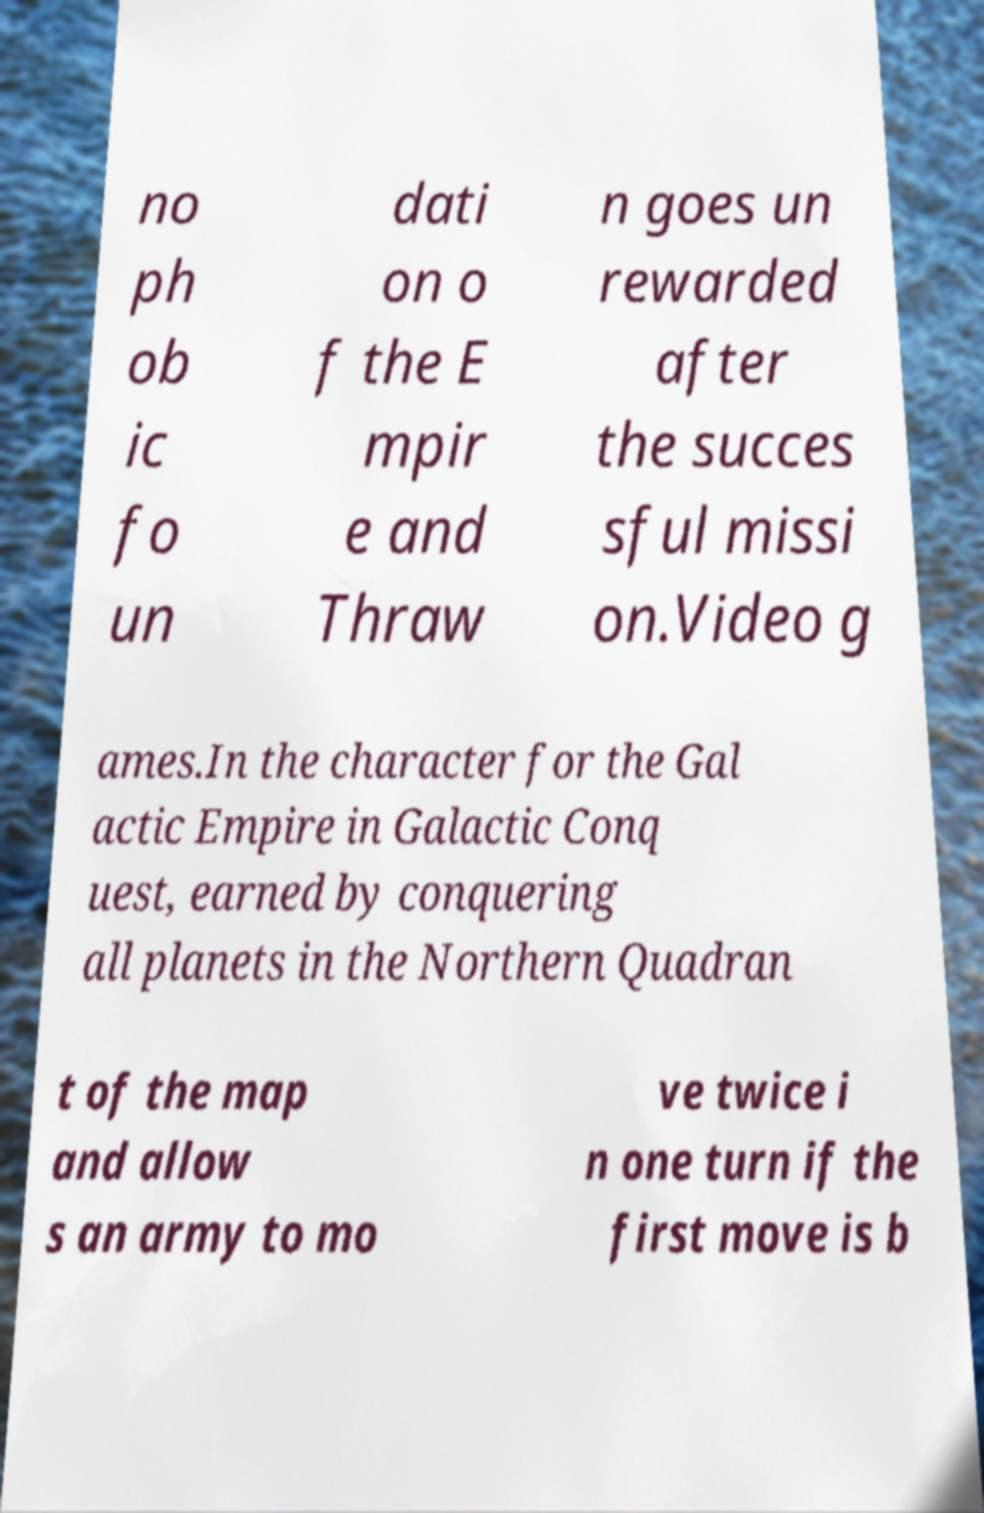Can you read and provide the text displayed in the image?This photo seems to have some interesting text. Can you extract and type it out for me? no ph ob ic fo un dati on o f the E mpir e and Thraw n goes un rewarded after the succes sful missi on.Video g ames.In the character for the Gal actic Empire in Galactic Conq uest, earned by conquering all planets in the Northern Quadran t of the map and allow s an army to mo ve twice i n one turn if the first move is b 